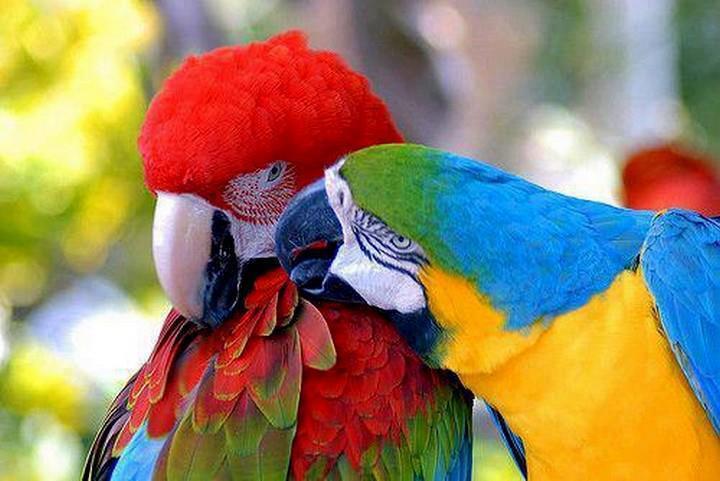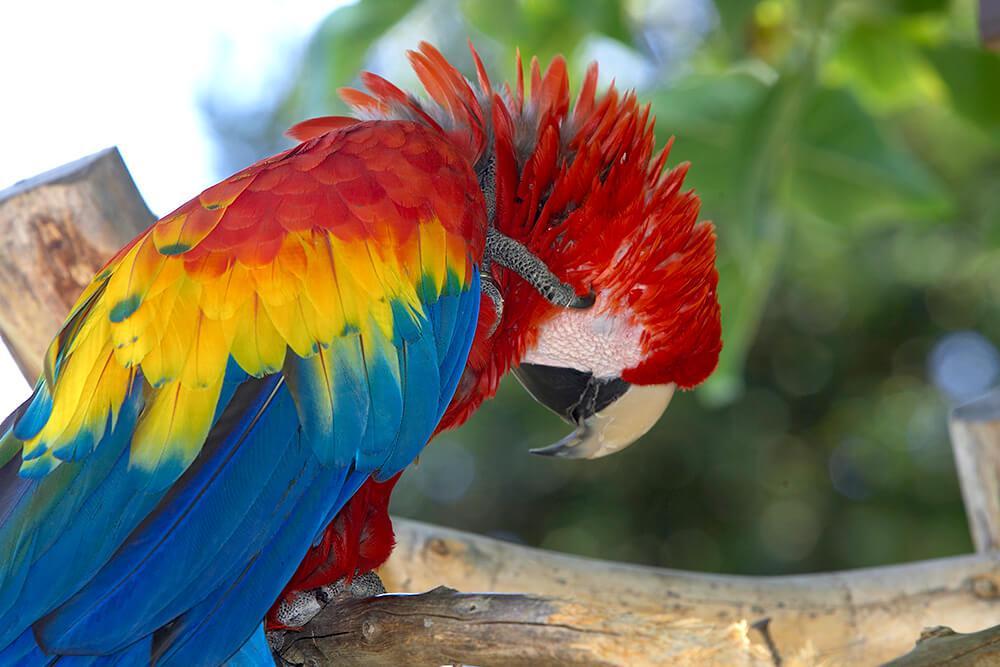The first image is the image on the left, the second image is the image on the right. For the images shown, is this caption "Atleast one photo has 2 birds" true? Answer yes or no. Yes. 